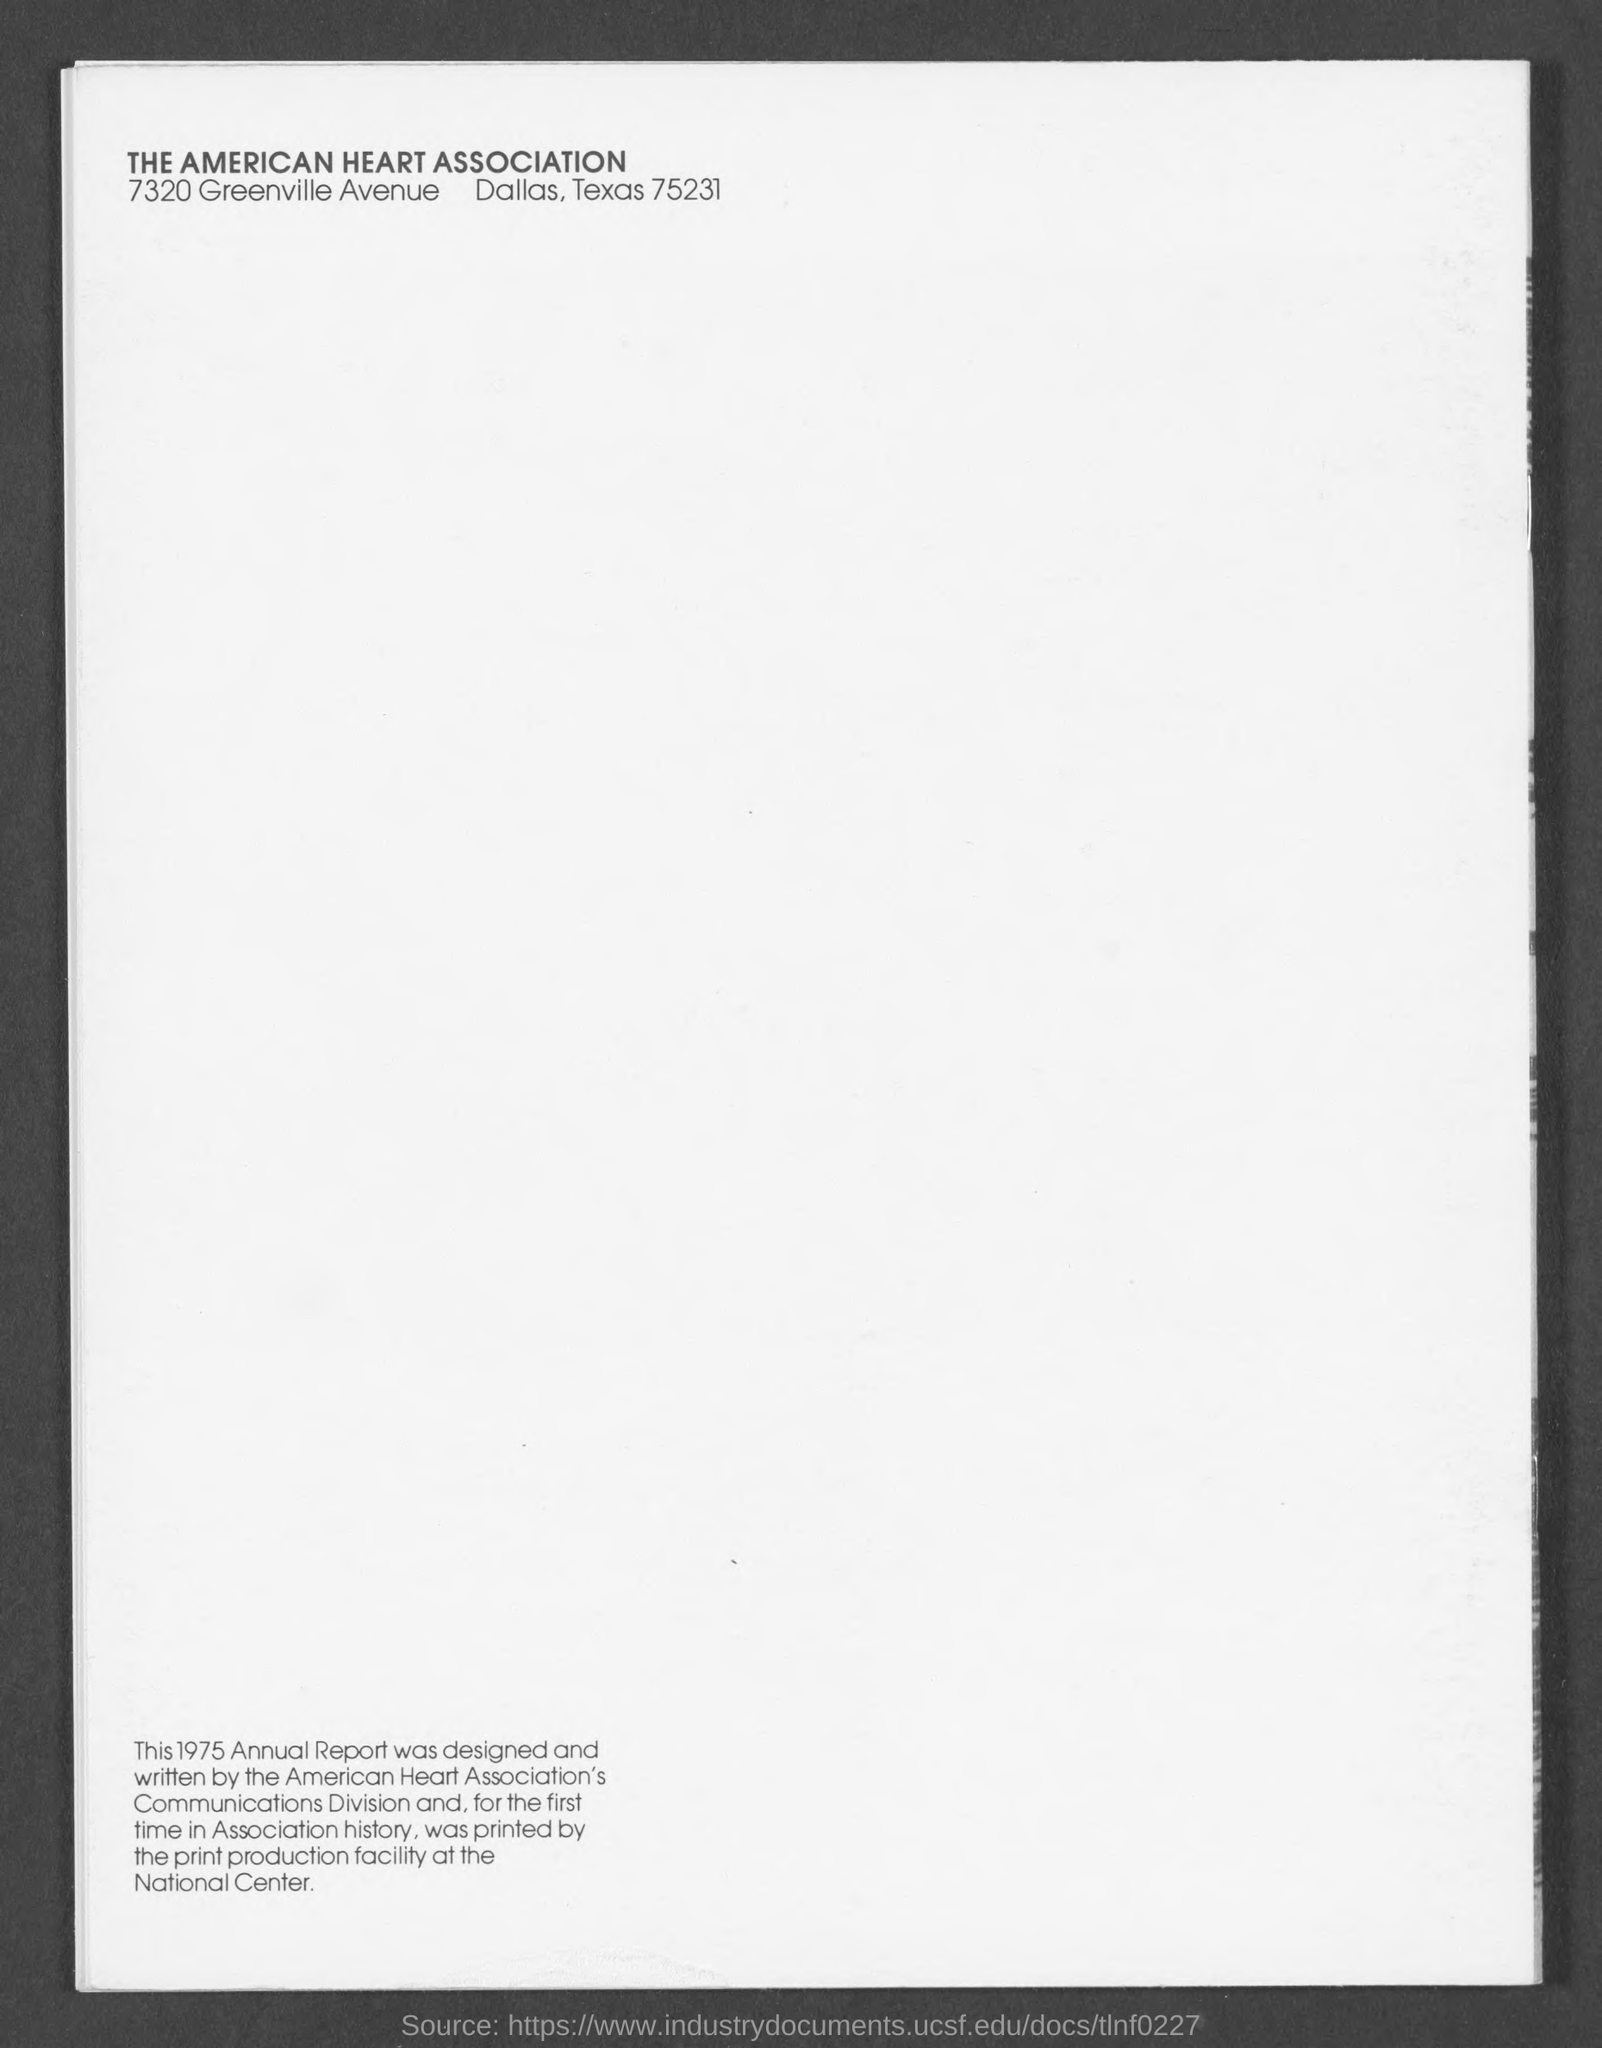Mention a couple of crucial points in this snapshot. The American Heart Association is located in a city with the name of Greenville Avenue. The American Heart Association is the name of a heart association. 